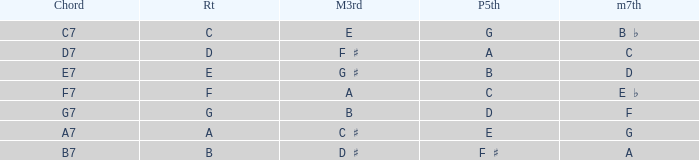What is the Perfect fifth with a Minor that is seventh of d? B. 